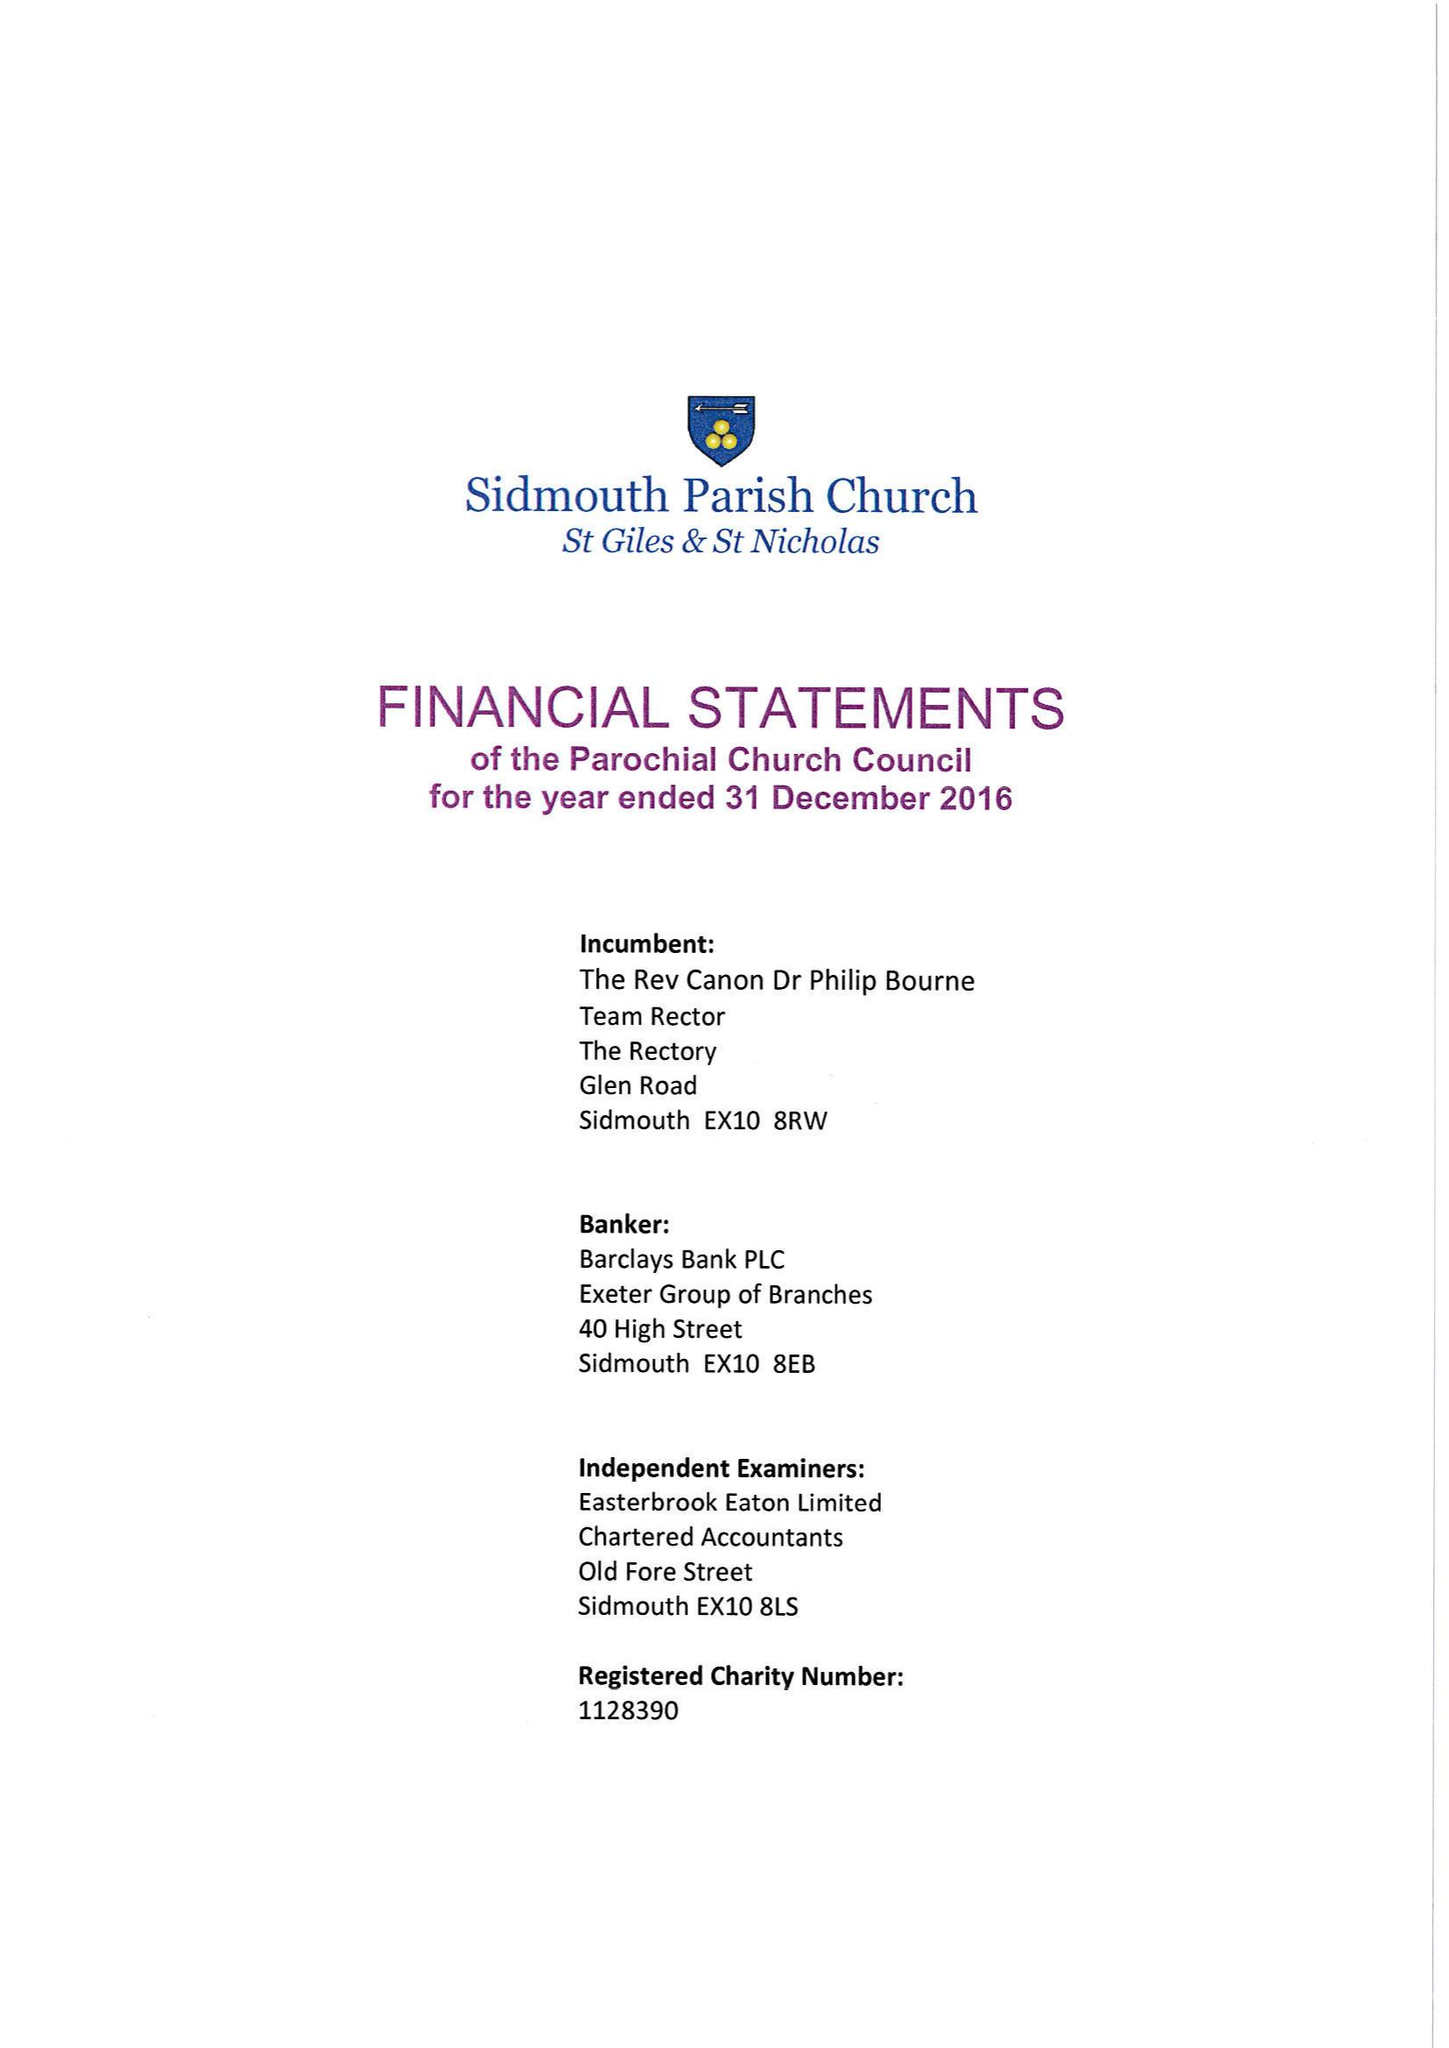What is the value for the report_date?
Answer the question using a single word or phrase. 2016-12-31 